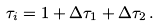<formula> <loc_0><loc_0><loc_500><loc_500>\tau _ { i } = 1 + \Delta \tau _ { 1 } + \Delta \tau _ { 2 } \, .</formula> 